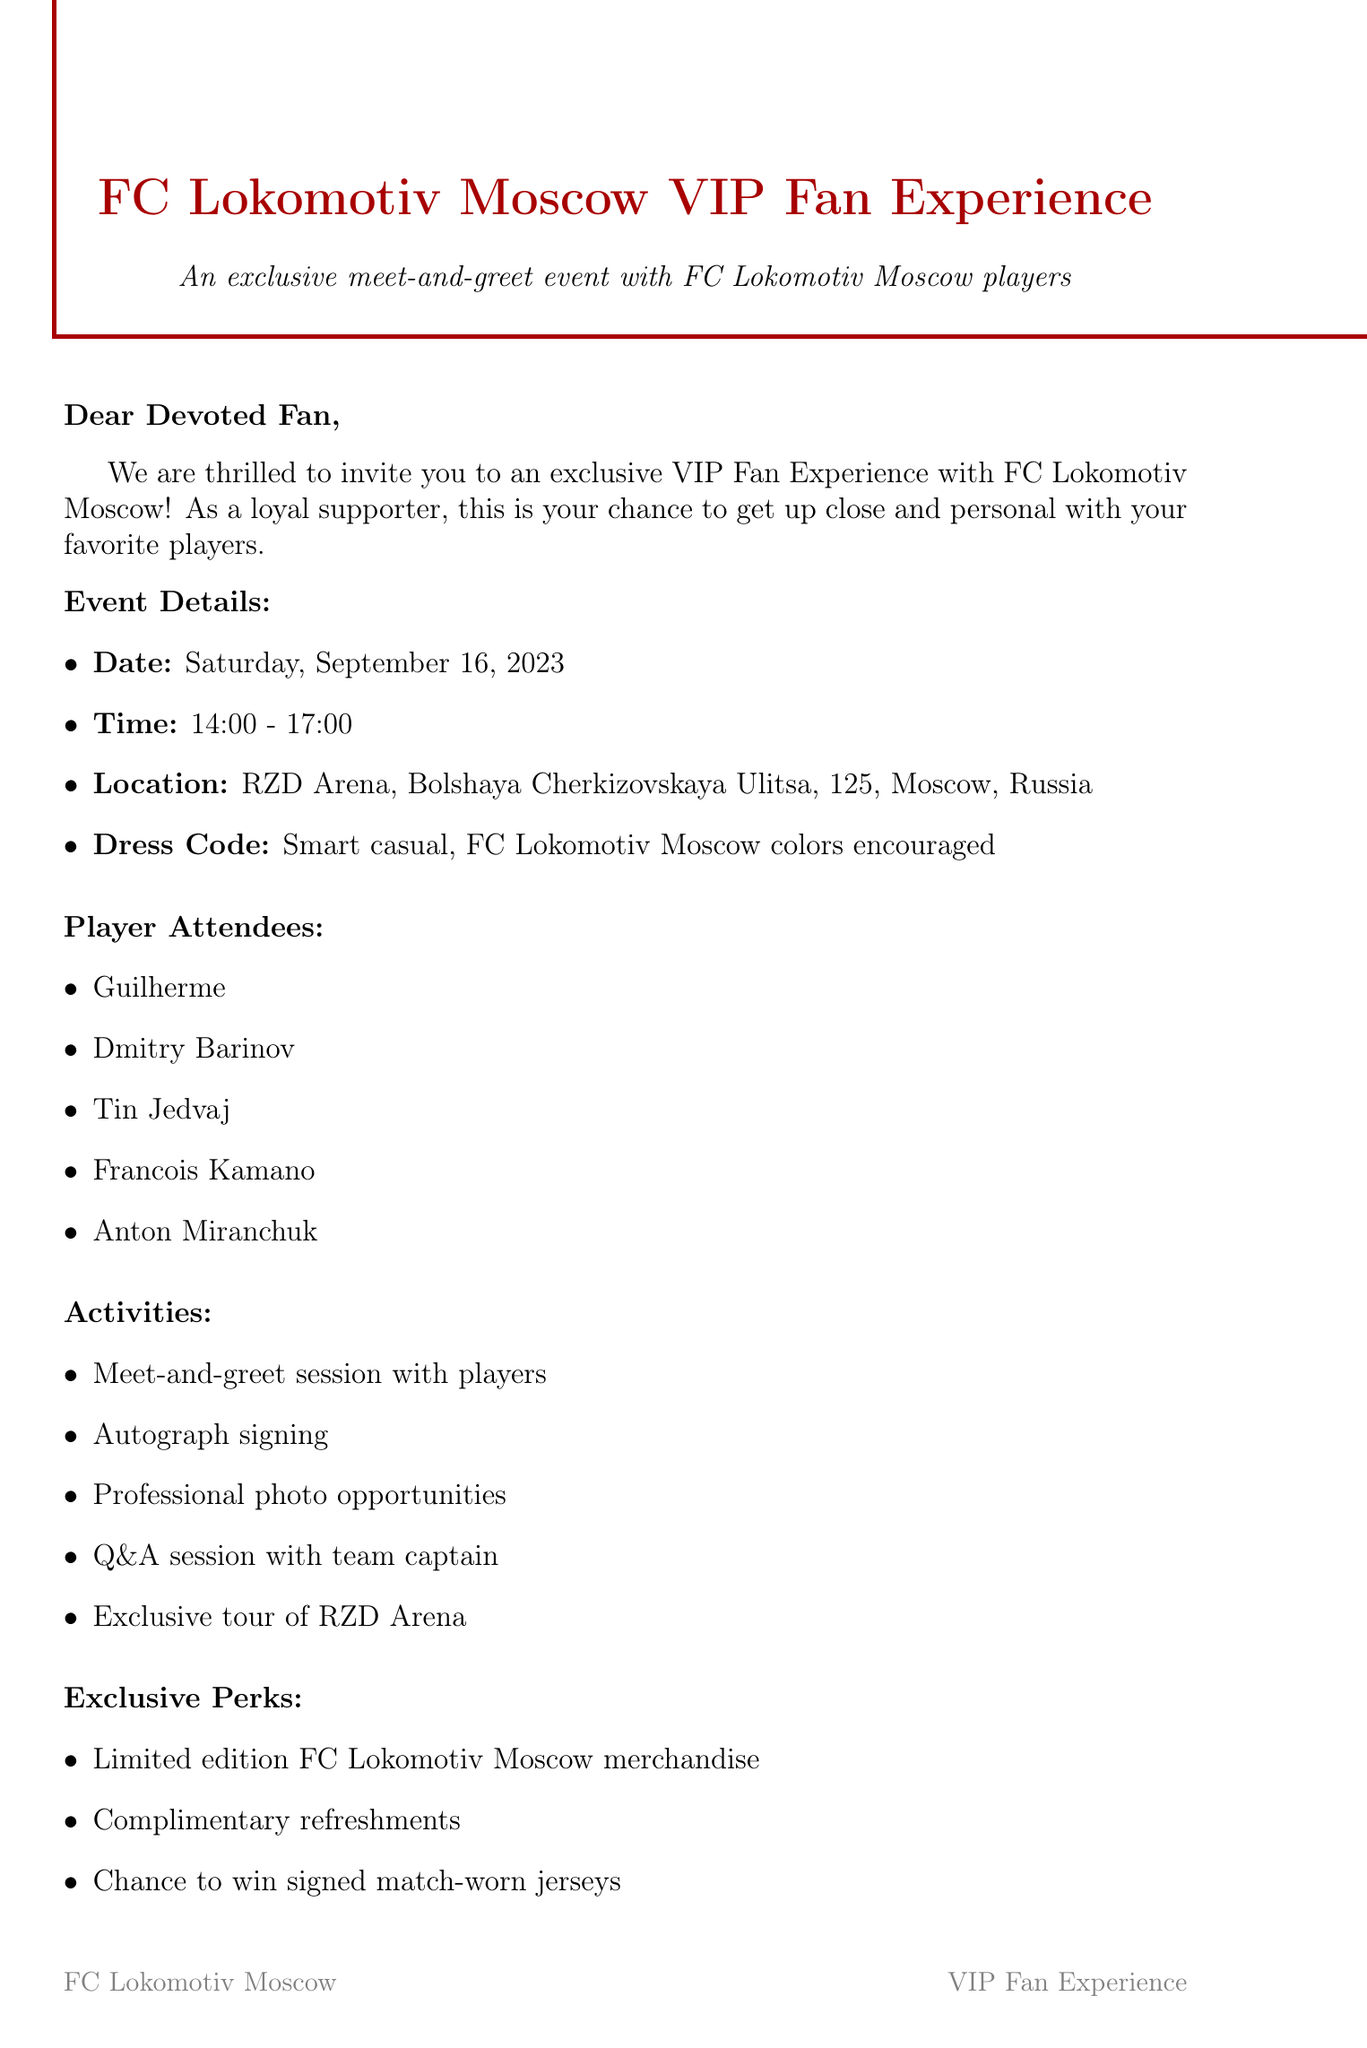What is the date of the event? The date is specified in the event details section of the document as "Saturday, September 16, 2023."
Answer: Saturday, September 16, 2023 What is the location of the event? The location can be found in the event details section and is given as "RZD Arena, Bolshaya Cherkizovskaya Ulitsa, 125, Moscow, Russia."
Answer: RZD Arena, Bolshaya Cherkizovskaya Ulitsa, 125, Moscow, Russia Who are some of the player attendees? The player attendees are listed in a specific section, including names such as "Guilherme," "Dmitry Barinov," and others.
Answer: Guilherme, Dmitry Barinov, Tin Jedvaj, Francois Kamano, Anton Miranchuk What activities are included in the event? The activities are detailed in a section, which includes items like "Meet-and-greet session with players," "Autograph signing," etc.
Answer: Meet-and-greet session with players, Autograph signing, Professional photo opportunities, Q&A session with team captain, Exclusive tour of RZD Arena What is the RSVP deadline? The RSVP deadline is mentioned in the document indicating when fans should confirm their attendance, specifically as "September 1, 2023."
Answer: September 1, 2023 What kind of refreshments will be available? The exclusive perks section mentions "Complimentary refreshments," which indicates what will be provided to the attendees.
Answer: Complimentary refreshments What are the COVID-19 precautions mentioned? The precautions listed involve several safety measures, including limited capacity and hand sanitizing stations, outlined in the COVID-19 precautions section.
Answer: Event capacity limited to ensure social distancing, Hand sanitizing stations available, Mask-wearing encouraged when not eating or drinking What metro station is nearest to the event? The nearest metro station is indicated within the transportation info section of the document as "Cherkizovskaya station."
Answer: Cherkizovskaya station 